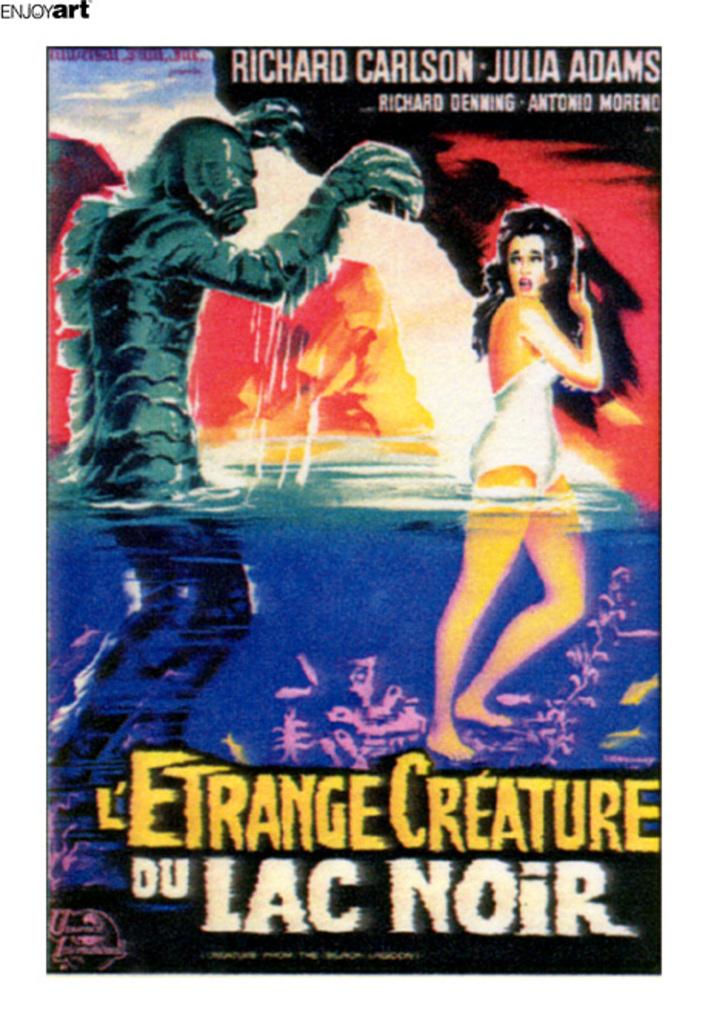Did richard carlson and julia adams make this together?
Your answer should be compact. Yes. What is the title of the poster?
Give a very brief answer. L'etrange creature du lac noir. 